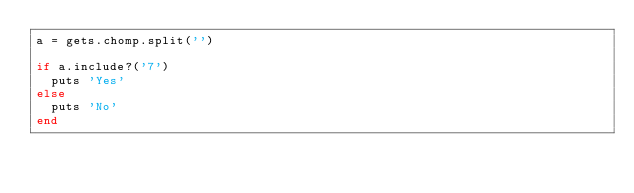<code> <loc_0><loc_0><loc_500><loc_500><_Ruby_>a = gets.chomp.split('')

if a.include?('7')
  puts 'Yes'
else
  puts 'No'
end
</code> 